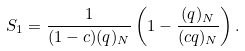Convert formula to latex. <formula><loc_0><loc_0><loc_500><loc_500>S _ { 1 } = \frac { 1 } { ( 1 - c ) ( q ) _ { N } } \left ( 1 - \frac { ( q ) _ { N } } { ( c q ) _ { N } } \right ) .</formula> 